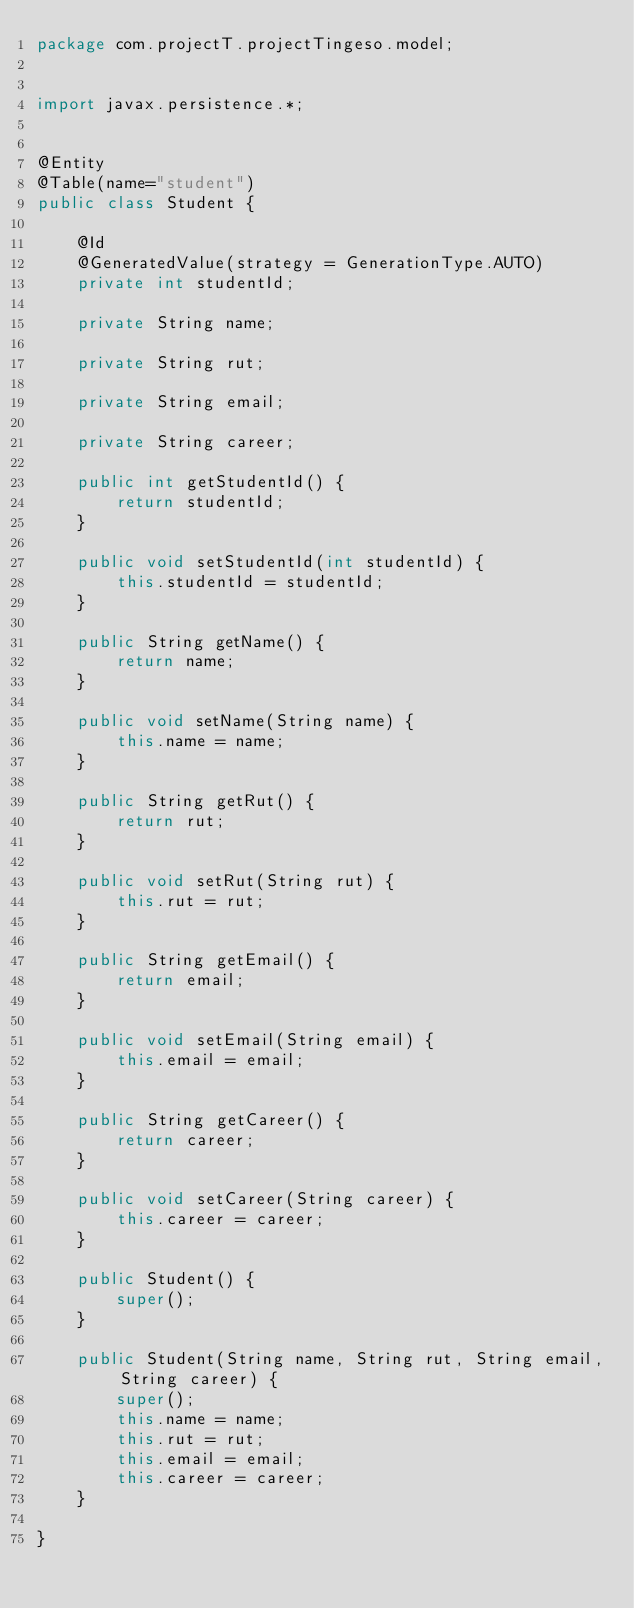Convert code to text. <code><loc_0><loc_0><loc_500><loc_500><_Java_>package com.projectT.projectTingeso.model;


import javax.persistence.*;


@Entity
@Table(name="student")
public class Student {

	@Id
    @GeneratedValue(strategy = GenerationType.AUTO)
    private int studentId;

	private String name;
    
    private String rut;
    
    private String email;
    
    private String career;
    
    public int getStudentId() {
		return studentId;
	}

	public void setStudentId(int studentId) {
		this.studentId = studentId;
	}

	public String getName() {
		return name;
	}

	public void setName(String name) {
		this.name = name;
	}

	public String getRut() {
		return rut;
	}

	public void setRut(String rut) {
		this.rut = rut;
	}

	public String getEmail() {
		return email;
	}

	public void setEmail(String email) {
		this.email = email;
	}

	public String getCareer() {
		return career;
	}

	public void setCareer(String career) {
		this.career = career;
	}
	
	public Student() {
		super();
	}
	
	public Student(String name, String rut, String email, String career) {
		super();
		this.name = name;
		this.rut = rut;
		this.email = email;
		this.career = career;
	}

}
</code> 